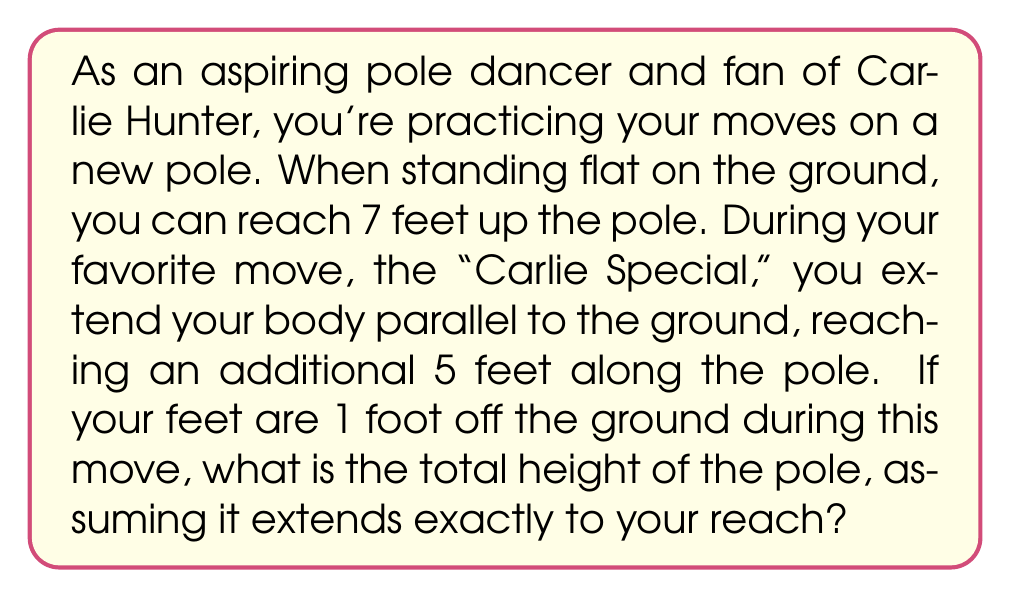Can you answer this question? Let's approach this step-by-step:

1) First, let's visualize the problem:
   [asy]
   import geometry;
   
   size(200);
   
   pair A = (0,0), B = (0,7), C = (5,1), D = (0,13);
   
   draw(A--D,black);
   draw(B--C,red);
   
   label("Ground", A, SW);
   label("7 ft", (0,3.5), W);
   label("5 ft", (2.5,1), S);
   label("1 ft", (5,0.5), E);
   label("Pole height", (0,10), E);
   
   dot(A); dot(B); dot(C);
   [/asy]

2) We can use the Pythagorean theorem to solve this problem. The dancer's body forms the hypotenuse of a right triangle.

3) Let $x$ be the unknown additional height of the pole above the dancer's standing reach.

4) We can form an equation:
   $$(7+x)^2 = 5^2 + (x-1)^2$$

5) Expanding this:
   $$49 + 14x + x^2 = 25 + x^2 - 2x + 1$$

6) Simplifying:
   $$49 + 14x = 26 - 2x$$
   $$23 = -16x$$
   $$x = \frac{23}{16} = 1.4375$$

7) So the additional height above the standing reach is 1.4375 feet.

8) The total pole height is therefore:
   $$7 + 1.4375 = 8.4375 \text{ feet}$$
Answer: The total height of the pole is 8.4375 feet or approximately 8 feet 5.25 inches. 